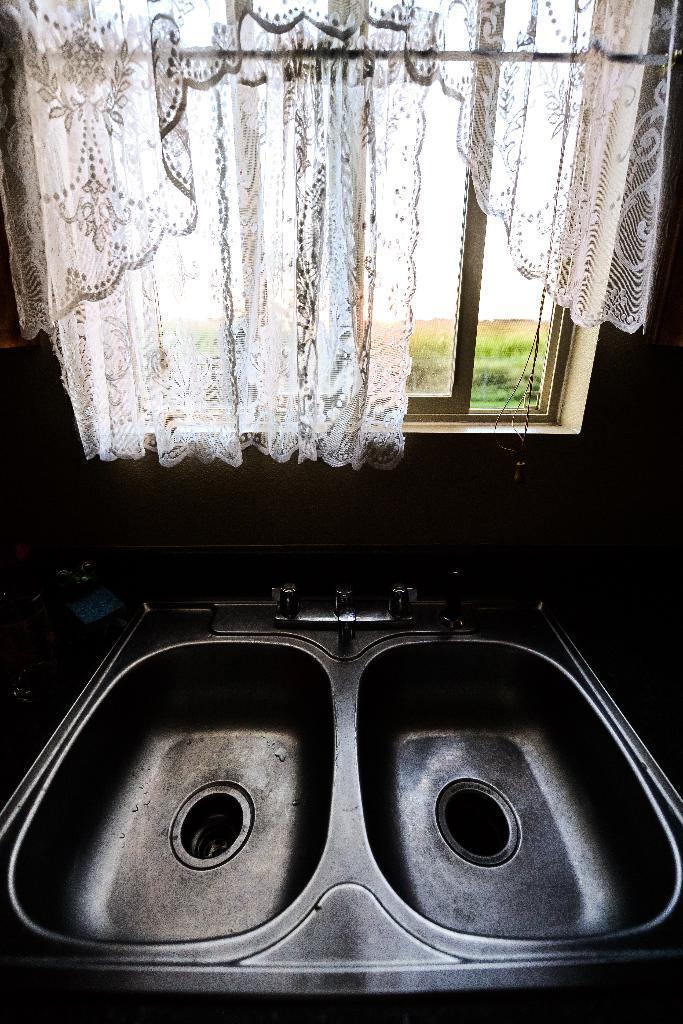Please provide a concise description of this image. In this picture there are sanitary equipment at the bottom side of the image, there is a window with curtain in the center of the image, there is greenery outside the window. 